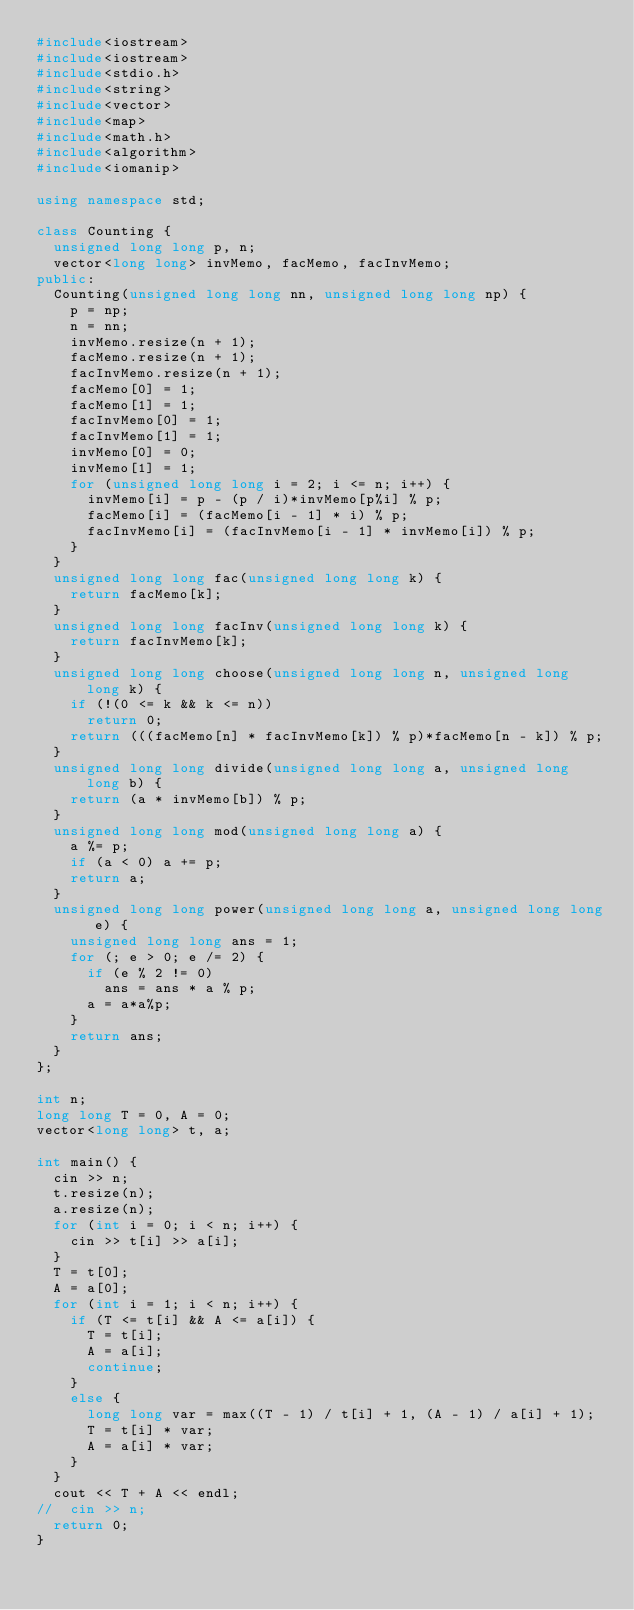Convert code to text. <code><loc_0><loc_0><loc_500><loc_500><_C++_>#include<iostream>
#include<iostream>
#include<stdio.h>
#include<string>
#include<vector>
#include<map>
#include<math.h>
#include<algorithm>
#include<iomanip>

using namespace std;

class Counting {
	unsigned long long p, n;
	vector<long long> invMemo, facMemo, facInvMemo;
public:
	Counting(unsigned long long nn, unsigned long long np) {
		p = np;
		n = nn;
		invMemo.resize(n + 1);
		facMemo.resize(n + 1);
		facInvMemo.resize(n + 1);
		facMemo[0] = 1;
		facMemo[1] = 1;
		facInvMemo[0] = 1;
		facInvMemo[1] = 1;
		invMemo[0] = 0;
		invMemo[1] = 1;
		for (unsigned long long i = 2; i <= n; i++) {
			invMemo[i] = p - (p / i)*invMemo[p%i] % p;
			facMemo[i] = (facMemo[i - 1] * i) % p;
			facInvMemo[i] = (facInvMemo[i - 1] * invMemo[i]) % p;
		}
	}
	unsigned long long fac(unsigned long long k) {
		return facMemo[k];
	}
	unsigned long long facInv(unsigned long long k) {
		return facInvMemo[k];
	}
	unsigned long long choose(unsigned long long n, unsigned long long k) {
		if (!(0 <= k && k <= n))
			return 0;
		return (((facMemo[n] * facInvMemo[k]) % p)*facMemo[n - k]) % p;
	}
	unsigned long long divide(unsigned long long a, unsigned long long b) {
		return (a * invMemo[b]) % p;
	}
	unsigned long long mod(unsigned long long a) {
		a %= p;
		if (a < 0) a += p;
		return a;
	}
	unsigned long long power(unsigned long long a, unsigned long long e) {
		unsigned long long ans = 1;
		for (; e > 0; e /= 2) {
			if (e % 2 != 0)
				ans = ans * a % p;
			a = a*a%p;
		}
		return ans;
	}
};

int n;
long long T = 0, A = 0;
vector<long long> t, a;

int main() {
	cin >> n;
	t.resize(n);
	a.resize(n);
	for (int i = 0; i < n; i++) {
		cin >> t[i] >> a[i];
	}
	T = t[0];
	A = a[0];
	for (int i = 1; i < n; i++) {
		if (T <= t[i] && A <= a[i]) {
			T = t[i];
			A = a[i];
			continue;
		}
		else {
			long long var = max((T - 1) / t[i] + 1, (A - 1) / a[i] + 1);
			T = t[i] * var;
			A = a[i] * var;
		}
	}
	cout << T + A << endl;
//	cin >> n;
	return 0;
}</code> 